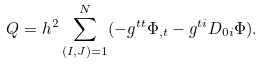Convert formula to latex. <formula><loc_0><loc_0><loc_500><loc_500>Q = h ^ { 2 } \sum _ { ( I , J ) = 1 } ^ { N } ( - g ^ { t t } \Phi _ { , t } - g ^ { t i } D _ { 0 i } \Phi ) .</formula> 